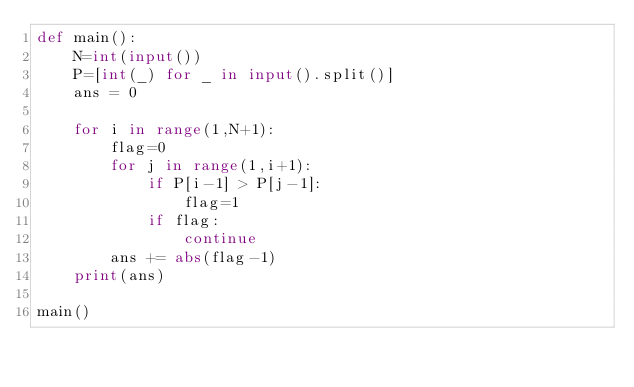<code> <loc_0><loc_0><loc_500><loc_500><_Python_>def main():
    N=int(input())
    P=[int(_) for _ in input().split()]
    ans = 0

    for i in range(1,N+1):
        flag=0
        for j in range(1,i+1):
            if P[i-1] > P[j-1]:
                flag=1
            if flag:
                continue
        ans += abs(flag-1)
    print(ans)

main()
</code> 